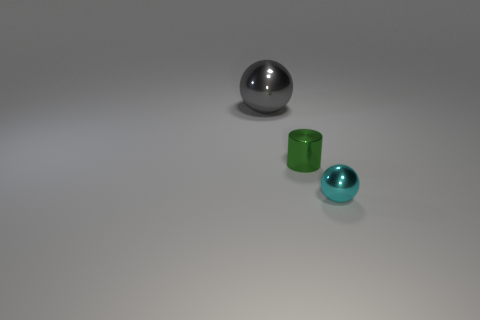Does the tiny ball have the same color as the large shiny sphere?
Ensure brevity in your answer.  No. Are there an equal number of cylinders in front of the big gray sphere and small cyan balls?
Your response must be concise. Yes. How many green metallic cylinders are there?
Your answer should be compact. 1. What shape is the metal object that is behind the small cyan shiny sphere and to the right of the large gray metallic sphere?
Offer a very short reply. Cylinder. Is the color of the object that is on the right side of the green shiny cylinder the same as the small thing that is to the left of the tiny shiny ball?
Offer a very short reply. No. Is there a green cylinder made of the same material as the tiny ball?
Offer a terse response. Yes. Are there the same number of small cyan balls on the left side of the gray sphere and small green things in front of the small green metallic object?
Your answer should be very brief. Yes. What size is the sphere in front of the green cylinder?
Ensure brevity in your answer.  Small. What material is the tiny thing behind the tiny object that is right of the green cylinder?
Your response must be concise. Metal. What number of gray shiny things are to the right of the ball behind the metallic ball that is right of the large metal object?
Provide a succinct answer. 0. 